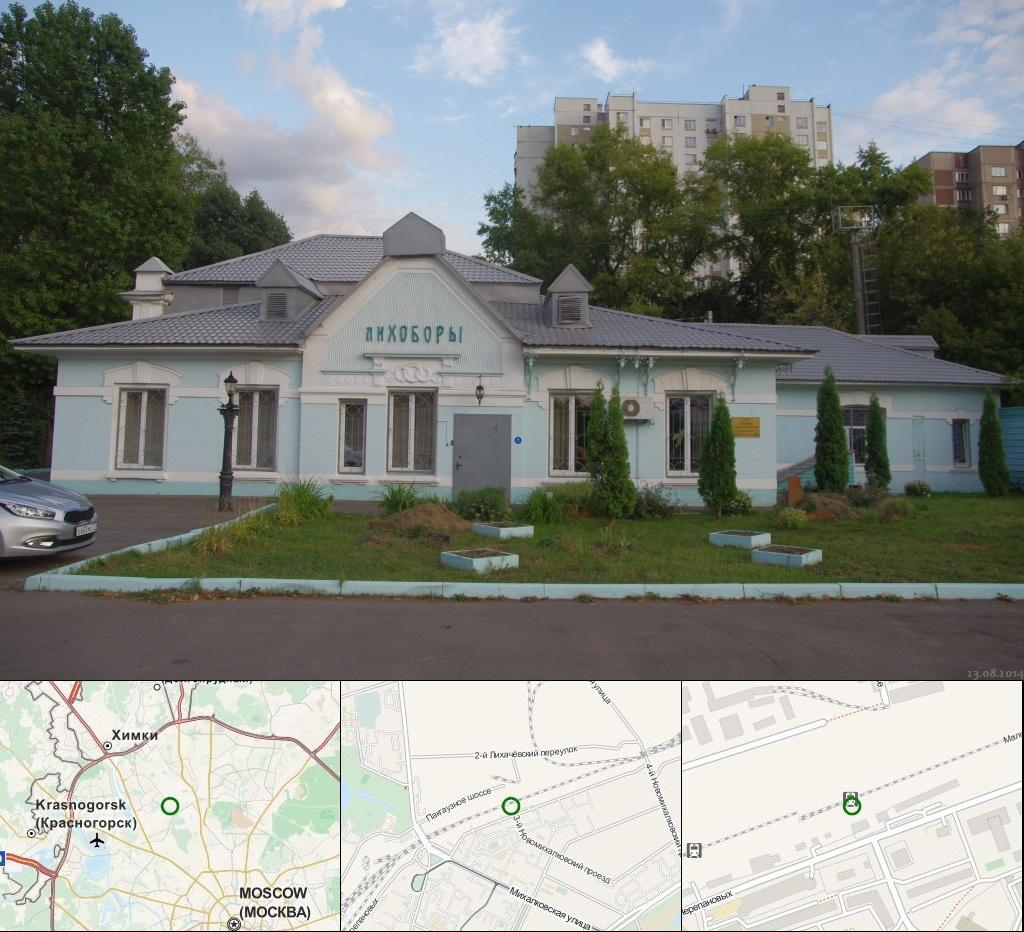What is the main object in the image? There is a board in the image. What can be seen in the background of the image? There is a vehicle, trees, a pole, a house with windows, and buildings visible in the background of the image. How many trees are visible in the image? There are many trees visible in the image. What else is visible in the sky? There are clouds visible in the image, and the sky is also visible. What type of popcorn is being served on the board in the image? There is no popcorn present in the image; it features a board with no food items. How many toes are visible on the board in the image? There are no toes visible on the board in the image, as it is a board without any human or animal presence. 